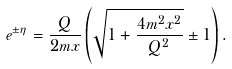Convert formula to latex. <formula><loc_0><loc_0><loc_500><loc_500>e ^ { \pm \eta } = \frac { Q } { 2 m x } \left ( \sqrt { 1 + \frac { 4 m ^ { 2 } x ^ { 2 } } { Q ^ { 2 } } } \pm 1 \right ) .</formula> 